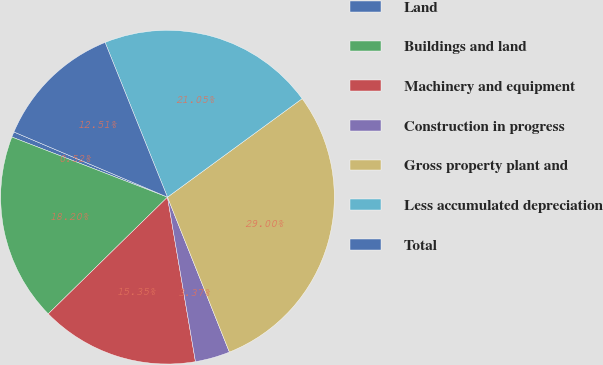<chart> <loc_0><loc_0><loc_500><loc_500><pie_chart><fcel>Land<fcel>Buildings and land<fcel>Machinery and equipment<fcel>Construction in progress<fcel>Gross property plant and<fcel>Less accumulated depreciation<fcel>Total<nl><fcel>0.52%<fcel>18.2%<fcel>15.35%<fcel>3.37%<fcel>29.0%<fcel>21.05%<fcel>12.51%<nl></chart> 